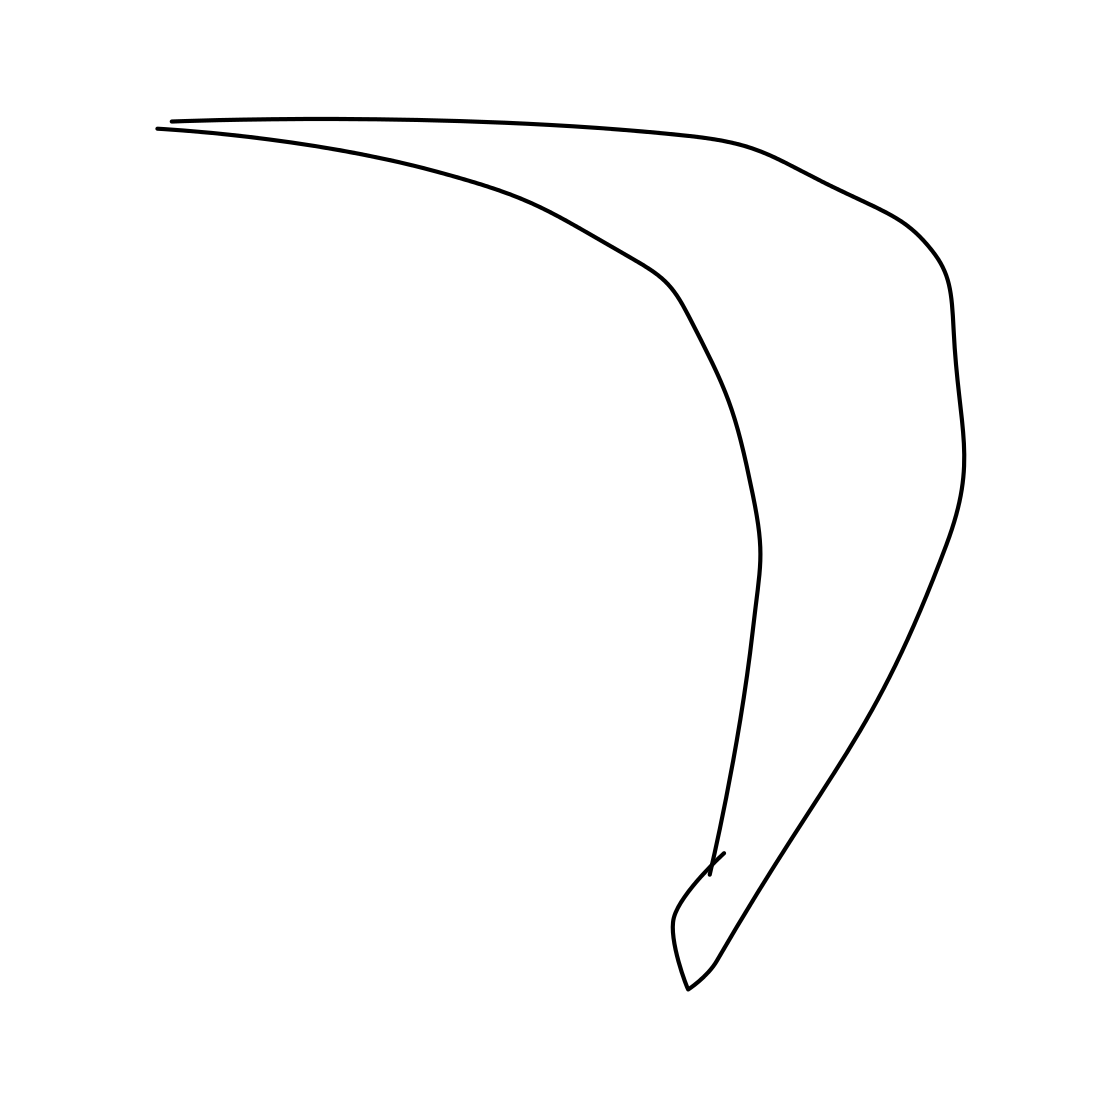Can you describe what this image might symbolize or represent in abstract art? This image, with its fluid and sweeping single stroke, might symbolize movement and simplicity. It could be interpreted as representing the minimalistic essence of an object in motion or a stylized representation of an element in nature, like a leaf or a wave. 